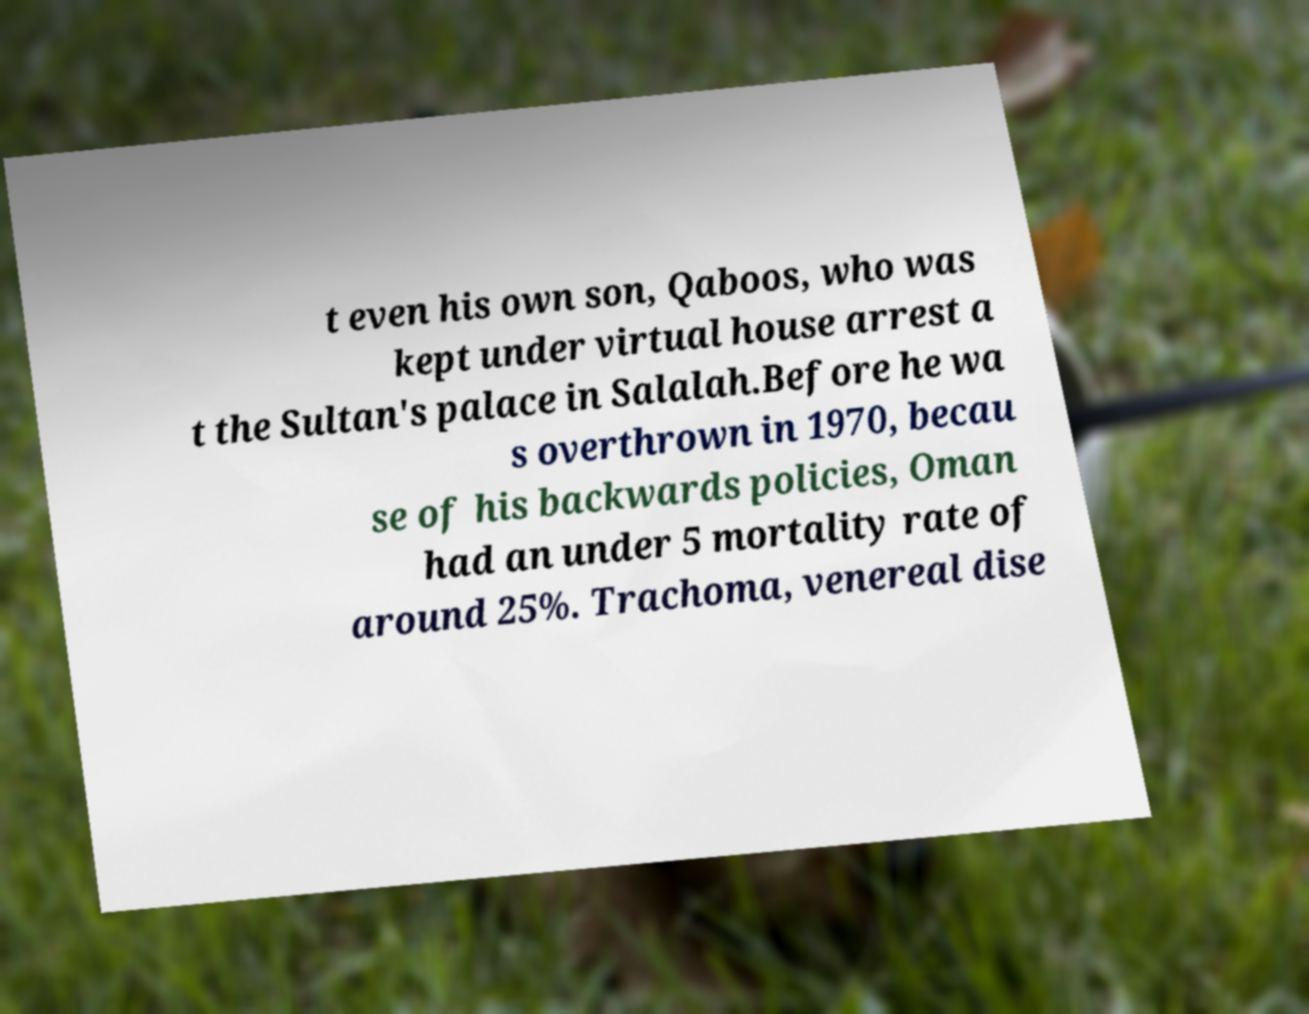For documentation purposes, I need the text within this image transcribed. Could you provide that? t even his own son, Qaboos, who was kept under virtual house arrest a t the Sultan's palace in Salalah.Before he wa s overthrown in 1970, becau se of his backwards policies, Oman had an under 5 mortality rate of around 25%. Trachoma, venereal dise 